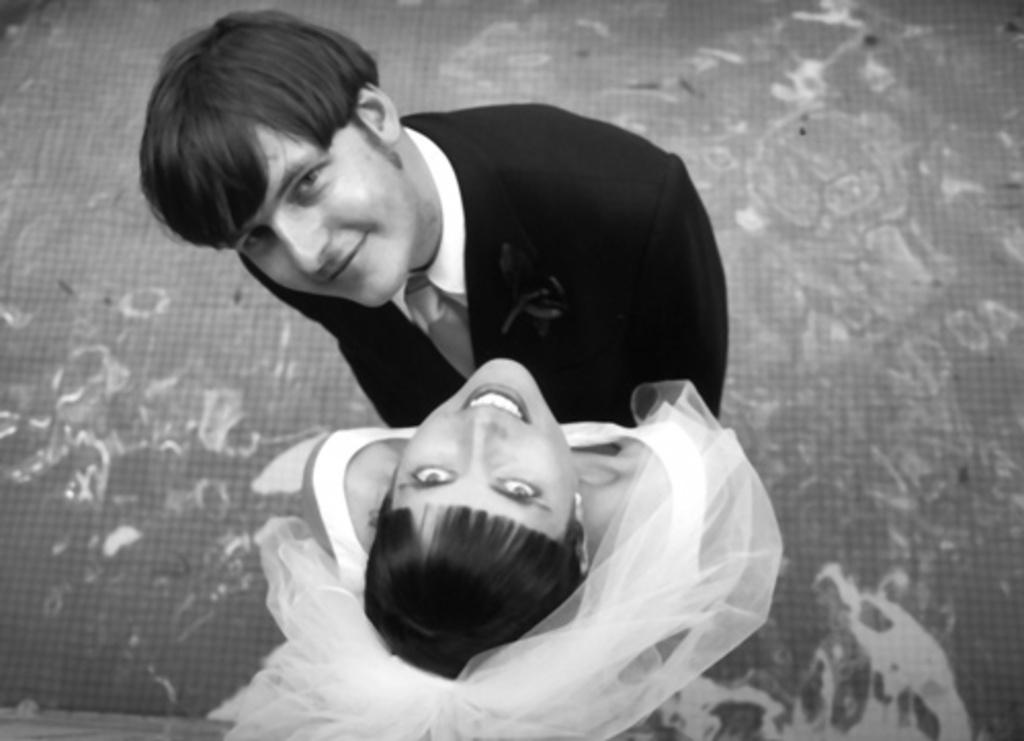How many people are present in the image? There are two people in the image, a man and a woman. What is the woman wearing that is unique to her appearance? The woman is wearing a veil. What is the color scheme of the image? The image is black and white. What type of weather can be seen in the image? There is no weather depicted in the image, as it is a black and white photograph of a man and a woman. Can you tell me what type of guitar the man is playing in the image? There is no guitar present in the image; it features a man and a woman. 